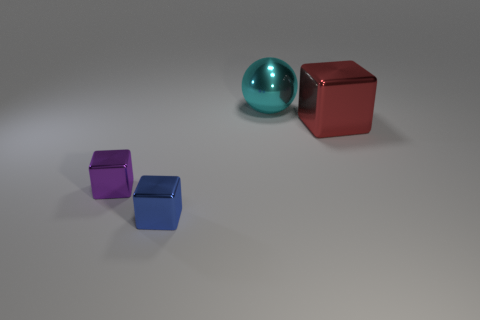Add 1 cyan spheres. How many objects exist? 5 Subtract all balls. How many objects are left? 3 Subtract 1 cyan balls. How many objects are left? 3 Subtract all large red rubber cylinders. Subtract all large cyan spheres. How many objects are left? 3 Add 4 purple shiny things. How many purple shiny things are left? 5 Add 4 big gray things. How many big gray things exist? 4 